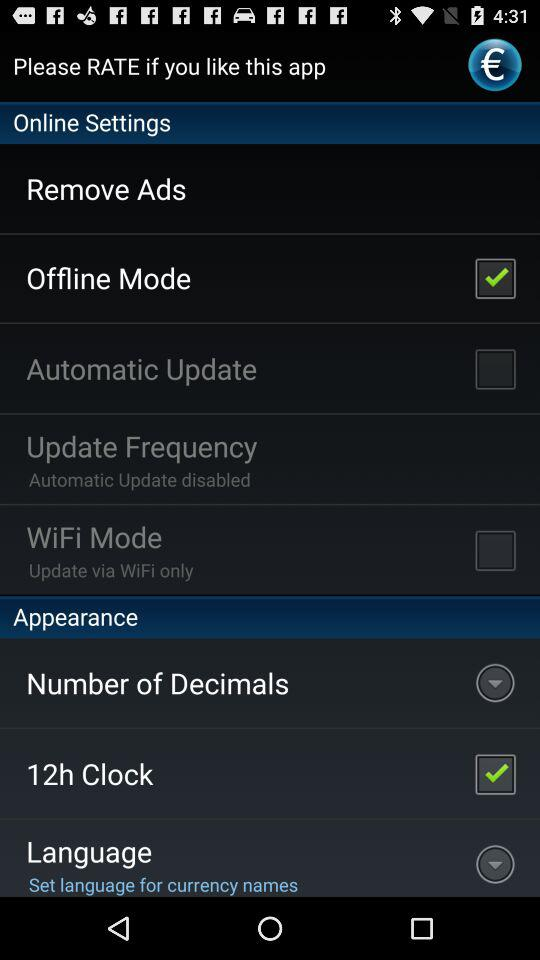Is "Appearance" selected or not selected"?
When the provided information is insufficient, respond with <no answer>. <no answer> 